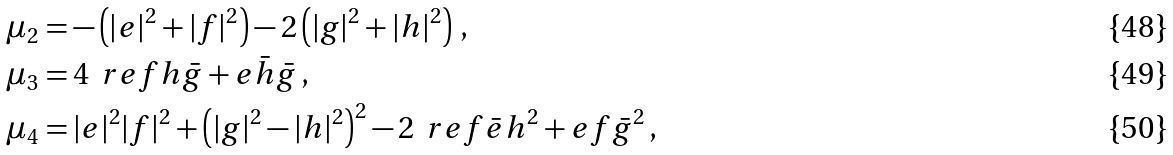<formula> <loc_0><loc_0><loc_500><loc_500>& \mu _ { 2 } = - \left ( | e | ^ { 2 } + | f | ^ { 2 } \right ) - 2 \left ( | g | ^ { 2 } + | h | ^ { 2 } \right ) \, , \\ & \mu _ { 3 } = 4 \, \ r e { f h \bar { g } + e \bar { h } \bar { g } } \, , \\ & \mu _ { 4 } = | e | ^ { 2 } | f | ^ { 2 } + \left ( | g | ^ { 2 } - | h | ^ { 2 } \right ) ^ { 2 } - 2 \, \ r e { f \bar { e } h ^ { 2 } + e f \bar { g } ^ { 2 } } \, ,</formula> 